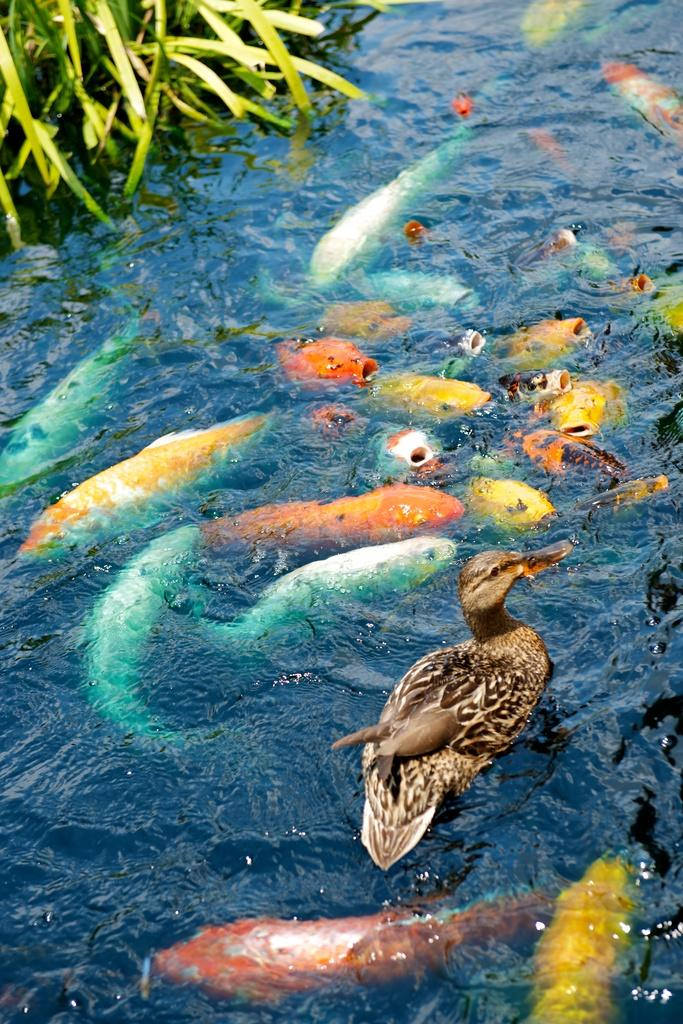What is the main element in the image? There is water in the image. What type of animal can be seen in the water? There is a duck in the water. What other creatures are present in the water? There are colorful fishes inside the water. What can be seen in the top left corner of the image? There are leaves in the top left corner of the image. What type of toys are floating in the water in the image? There are no toys present in the image; it features include water, a duck, colorful fishes, and leaves. What kind of creature is swimming alongside the duck in the image? There is no other creature swimming alongside the duck in the image; only the duck and the colorful fishes are present. 